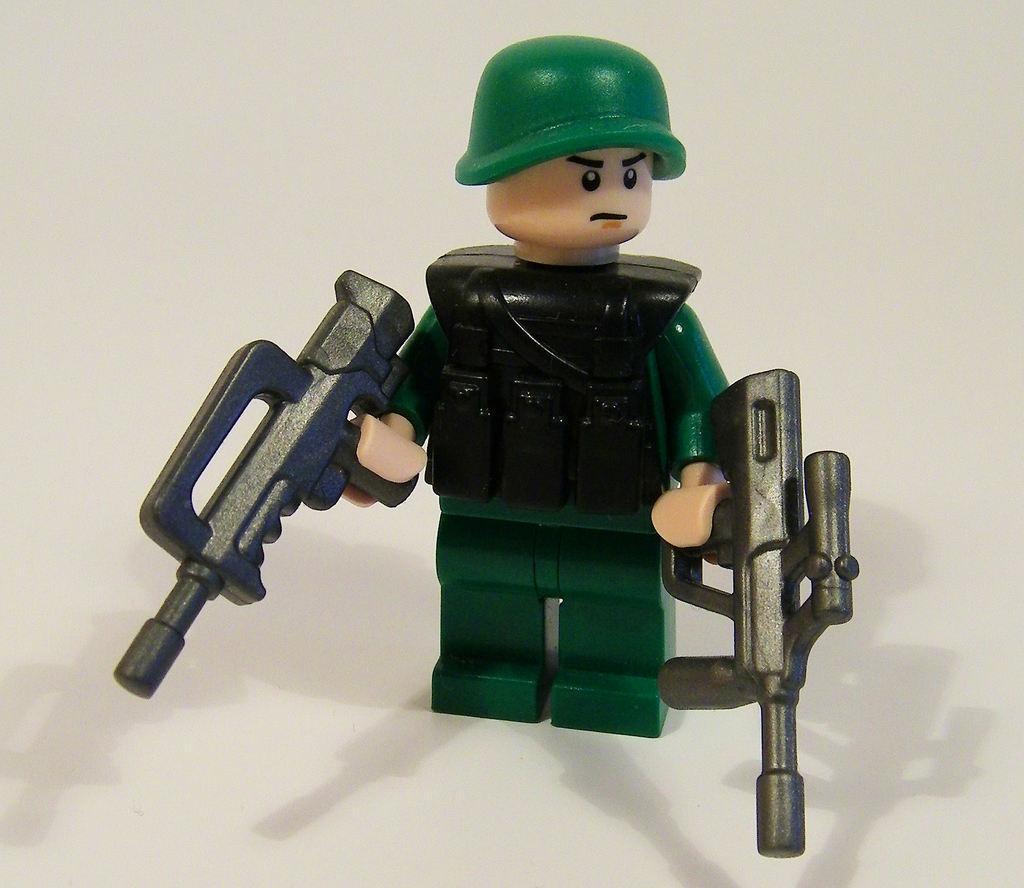Can you describe this image briefly? In the center of the picture there is a toy holding guns and helmet. The toy is on a white surface. 